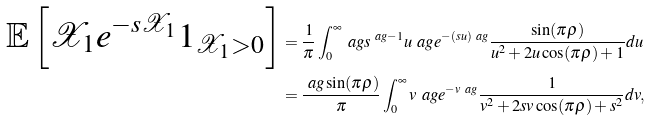Convert formula to latex. <formula><loc_0><loc_0><loc_500><loc_500>\mathbb { E } \left [ \mathcal { X } _ { 1 } e ^ { - s \mathcal { X } _ { 1 } } \boldsymbol 1 _ { \mathcal { X } _ { 1 } > 0 } \right ] & = \frac { 1 } { \pi } \int _ { 0 } ^ { \infty } \ a g s ^ { \ a g - 1 } u ^ { \ } a g e ^ { - ( s u ) ^ { \ } a g } \frac { \sin ( \pi \rho ) } { u ^ { 2 } + 2 u \cos ( \pi \rho ) + 1 } d u \\ & = \frac { \ a g \sin ( \pi \rho ) } { \pi } \int _ { 0 } ^ { \infty } v ^ { \ } a g e ^ { - v ^ { \ } a g } \frac { 1 } { v ^ { 2 } + 2 s v \cos ( \pi \rho ) + s ^ { 2 } } d v ,</formula> 